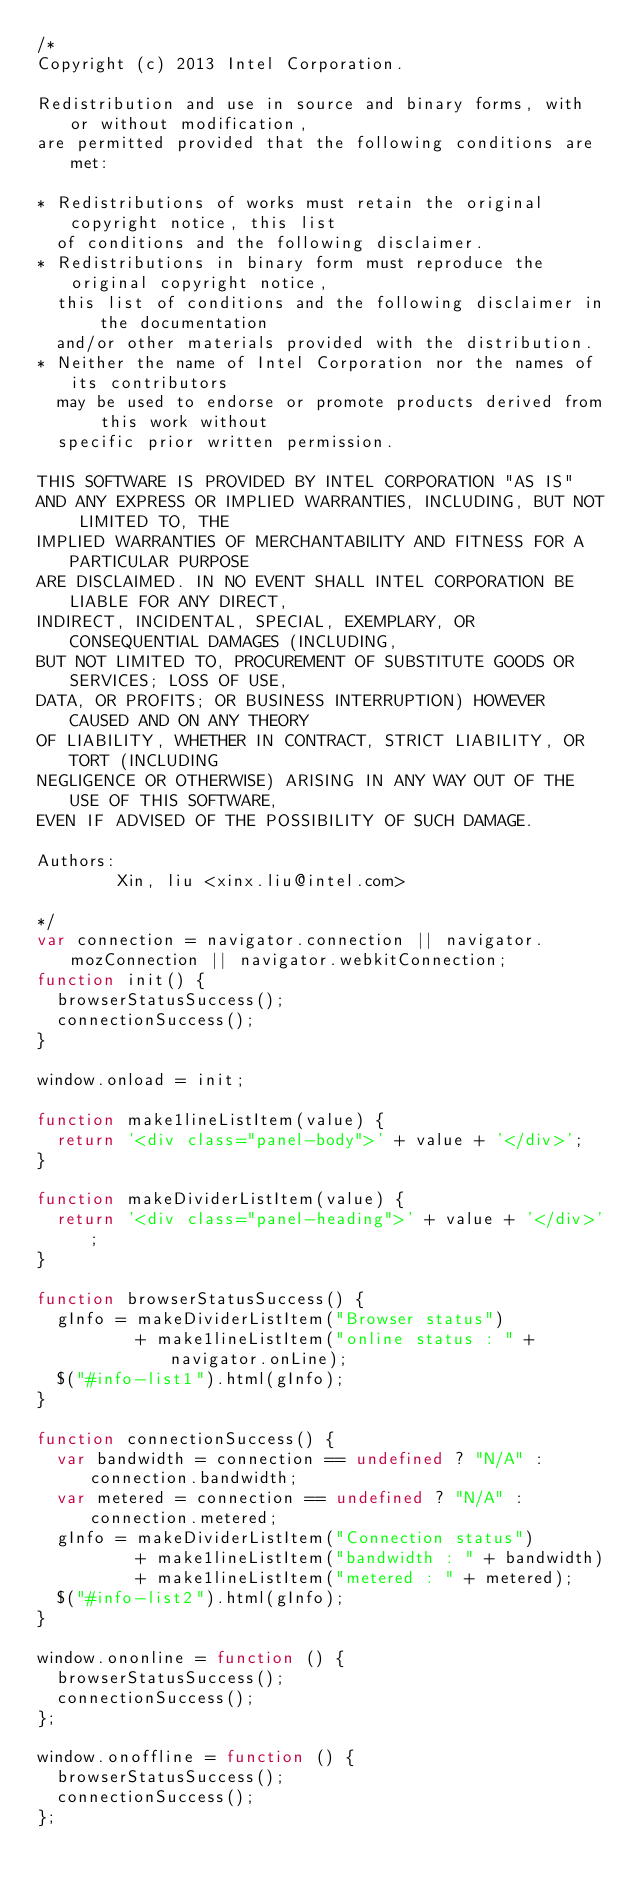Convert code to text. <code><loc_0><loc_0><loc_500><loc_500><_JavaScript_>/*
Copyright (c) 2013 Intel Corporation.

Redistribution and use in source and binary forms, with or without modification,
are permitted provided that the following conditions are met:

* Redistributions of works must retain the original copyright notice, this list
  of conditions and the following disclaimer.
* Redistributions in binary form must reproduce the original copyright notice,
  this list of conditions and the following disclaimer in the documentation
  and/or other materials provided with the distribution.
* Neither the name of Intel Corporation nor the names of its contributors
  may be used to endorse or promote products derived from this work without
  specific prior written permission.

THIS SOFTWARE IS PROVIDED BY INTEL CORPORATION "AS IS"
AND ANY EXPRESS OR IMPLIED WARRANTIES, INCLUDING, BUT NOT LIMITED TO, THE
IMPLIED WARRANTIES OF MERCHANTABILITY AND FITNESS FOR A PARTICULAR PURPOSE
ARE DISCLAIMED. IN NO EVENT SHALL INTEL CORPORATION BE LIABLE FOR ANY DIRECT,
INDIRECT, INCIDENTAL, SPECIAL, EXEMPLARY, OR CONSEQUENTIAL DAMAGES (INCLUDING,
BUT NOT LIMITED TO, PROCUREMENT OF SUBSTITUTE GOODS OR SERVICES; LOSS OF USE,
DATA, OR PROFITS; OR BUSINESS INTERRUPTION) HOWEVER CAUSED AND ON ANY THEORY
OF LIABILITY, WHETHER IN CONTRACT, STRICT LIABILITY, OR TORT (INCLUDING
NEGLIGENCE OR OTHERWISE) ARISING IN ANY WAY OUT OF THE USE OF THIS SOFTWARE,
EVEN IF ADVISED OF THE POSSIBILITY OF SUCH DAMAGE.

Authors:
        Xin, liu <xinx.liu@intel.com>

*/
var connection = navigator.connection || navigator.mozConnection || navigator.webkitConnection;
function init() {
  browserStatusSuccess();
  connectionSuccess();
}

window.onload = init;

function make1lineListItem(value) {
  return '<div class="panel-body">' + value + '</div>';
}

function makeDividerListItem(value) {
  return '<div class="panel-heading">' + value + '</div>';
}

function browserStatusSuccess() {
  gInfo = makeDividerListItem("Browser status")
          + make1lineListItem("online status : " + navigator.onLine);
  $("#info-list1").html(gInfo);
}

function connectionSuccess() {
  var bandwidth = connection == undefined ? "N/A" : connection.bandwidth;
  var metered = connection == undefined ? "N/A" : connection.metered;
  gInfo = makeDividerListItem("Connection status")
          + make1lineListItem("bandwidth : " + bandwidth)
          + make1lineListItem("metered : " + metered);
  $("#info-list2").html(gInfo);
}

window.ononline = function () {
  browserStatusSuccess();
  connectionSuccess();
};

window.onoffline = function () {
  browserStatusSuccess();
  connectionSuccess();
};
</code> 